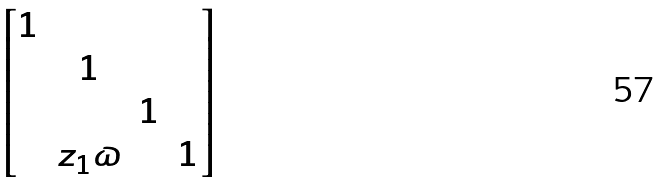<formula> <loc_0><loc_0><loc_500><loc_500>\begin{bmatrix} 1 \\ & 1 \\ & & 1 \\ & z _ { 1 } \varpi & & 1 \end{bmatrix}</formula> 